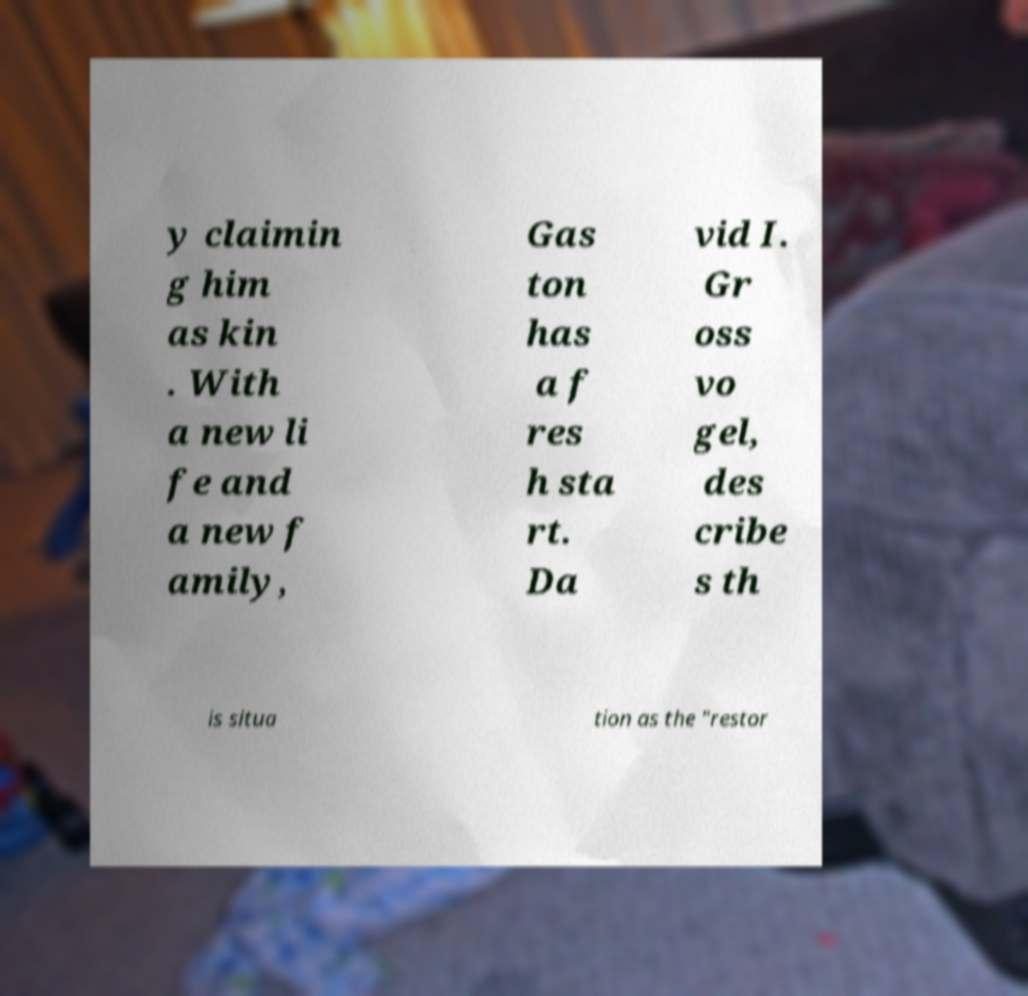Can you accurately transcribe the text from the provided image for me? y claimin g him as kin . With a new li fe and a new f amily, Gas ton has a f res h sta rt. Da vid I. Gr oss vo gel, des cribe s th is situa tion as the "restor 